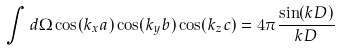<formula> <loc_0><loc_0><loc_500><loc_500>\int d \Omega \cos ( k _ { x } a ) \cos ( k _ { y } b ) \cos ( k _ { z } c ) = 4 \pi \frac { \sin ( k D ) } { k D }</formula> 